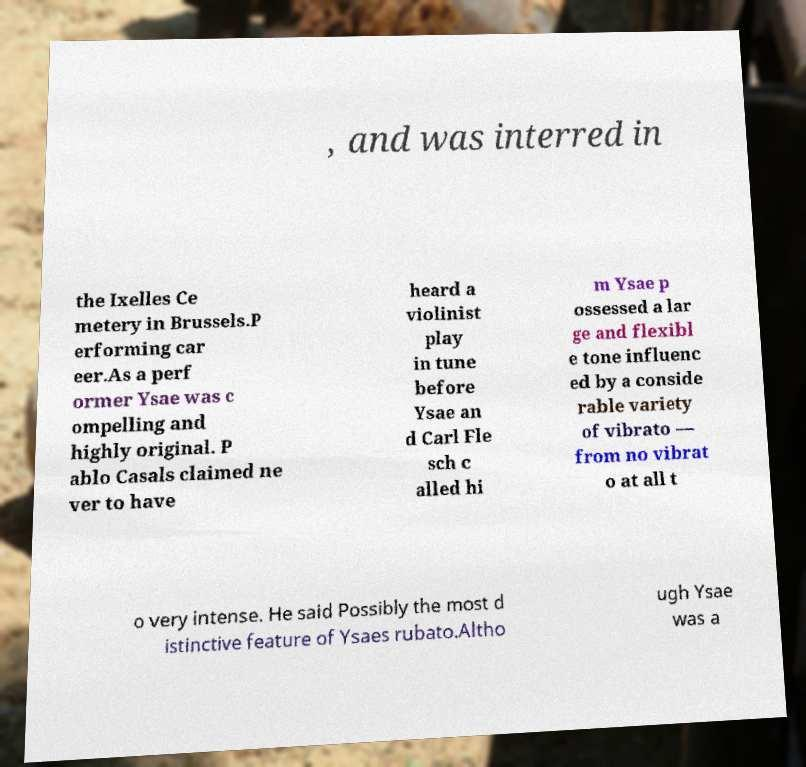Can you accurately transcribe the text from the provided image for me? , and was interred in the Ixelles Ce metery in Brussels.P erforming car eer.As a perf ormer Ysae was c ompelling and highly original. P ablo Casals claimed ne ver to have heard a violinist play in tune before Ysae an d Carl Fle sch c alled hi m Ysae p ossessed a lar ge and flexibl e tone influenc ed by a conside rable variety of vibrato — from no vibrat o at all t o very intense. He said Possibly the most d istinctive feature of Ysaes rubato.Altho ugh Ysae was a 